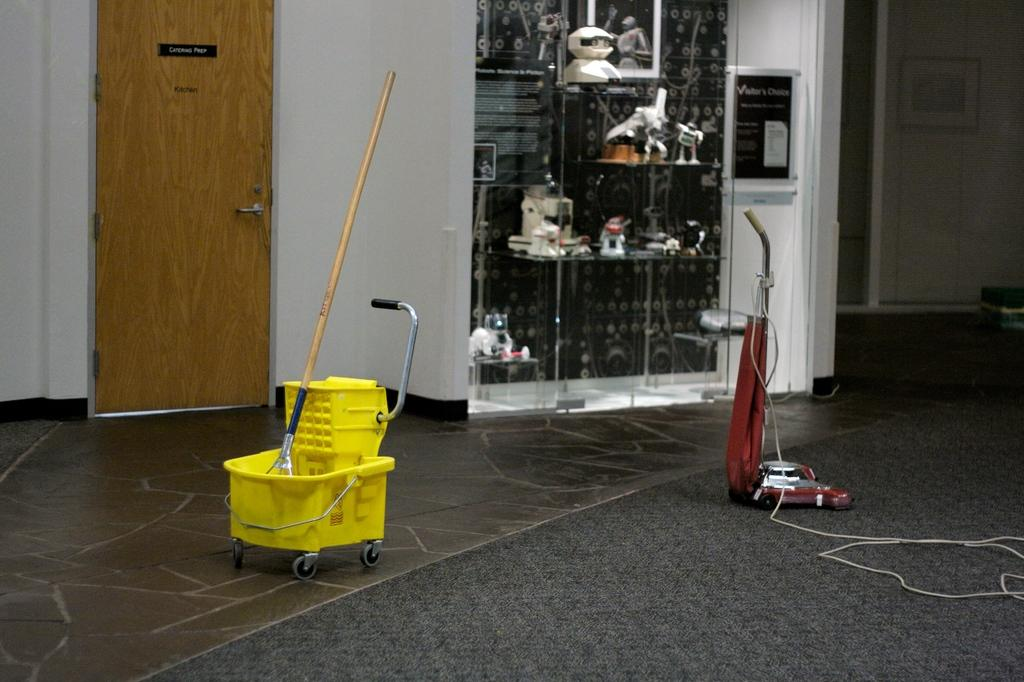What cleaning equipment is present on the floor in the image? There is a mop bucket and a vacuum cleaner on the floor in the image. What can be seen at the top of the image? There is a rack at the top of the image. Is there any entrance or exit visible in the image? Yes, there is a door in the top left of the image. What type of tent can be seen in the image? There is no tent present in the image. What wire is connected to the vacuum cleaner in the image? There is no wire connected to the vacuum cleaner in the image. 